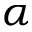<formula> <loc_0><loc_0><loc_500><loc_500>\alpha</formula> 